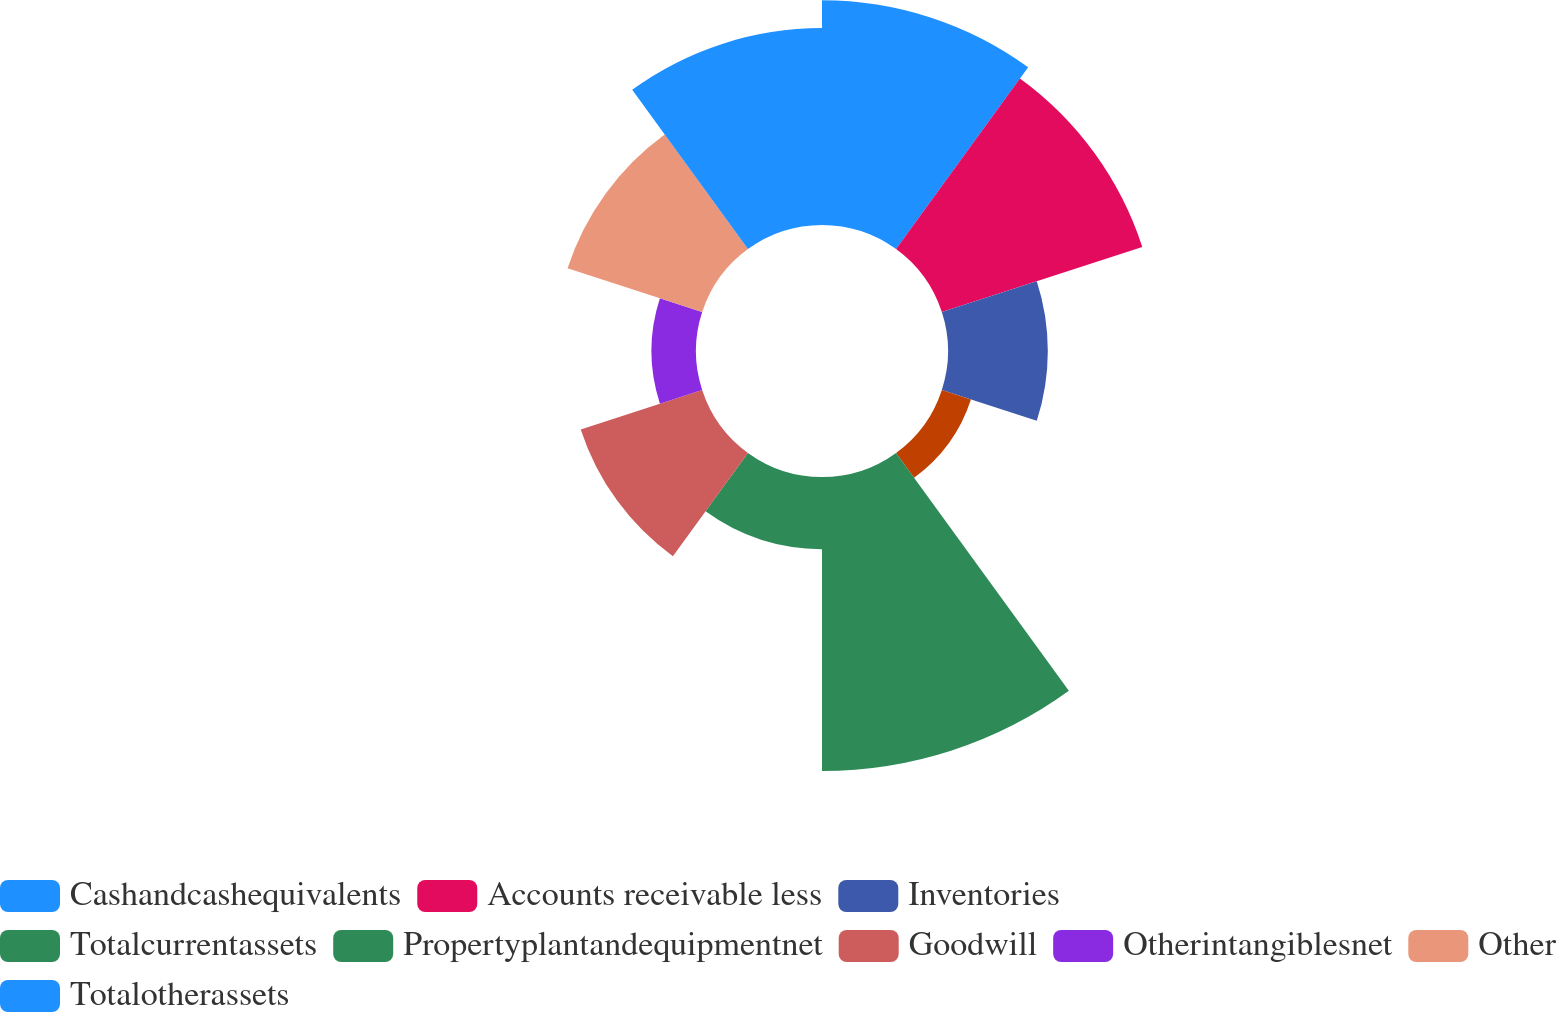Convert chart to OTSL. <chart><loc_0><loc_0><loc_500><loc_500><pie_chart><fcel>Cashandcashequivalents<fcel>Accounts receivable less<fcel>Inventories<fcel>Unnamed: 3<fcel>Totalcurrentassets<fcel>Propertyplantandequipmentnet<fcel>Goodwill<fcel>Otherintangiblesnet<fcel>Other<fcel>Totalotherassets<nl><fcel>15.58%<fcel>14.61%<fcel>6.92%<fcel>2.12%<fcel>20.38%<fcel>5.0%<fcel>8.85%<fcel>3.08%<fcel>9.81%<fcel>13.65%<nl></chart> 